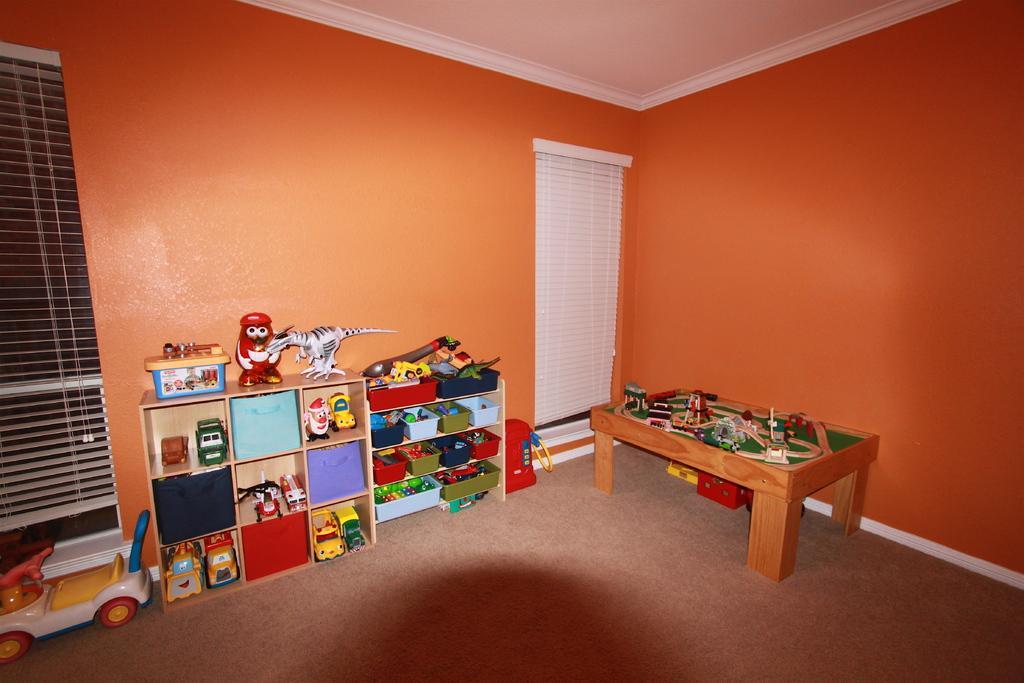How would you summarize this image in a sentence or two? In this image it seems like there are toys which are kept in shelves and a table beside it,on which there are railway track toys and playing toys on it. At the background there is a wall and the curtain. At the bottom there is a toy car. 